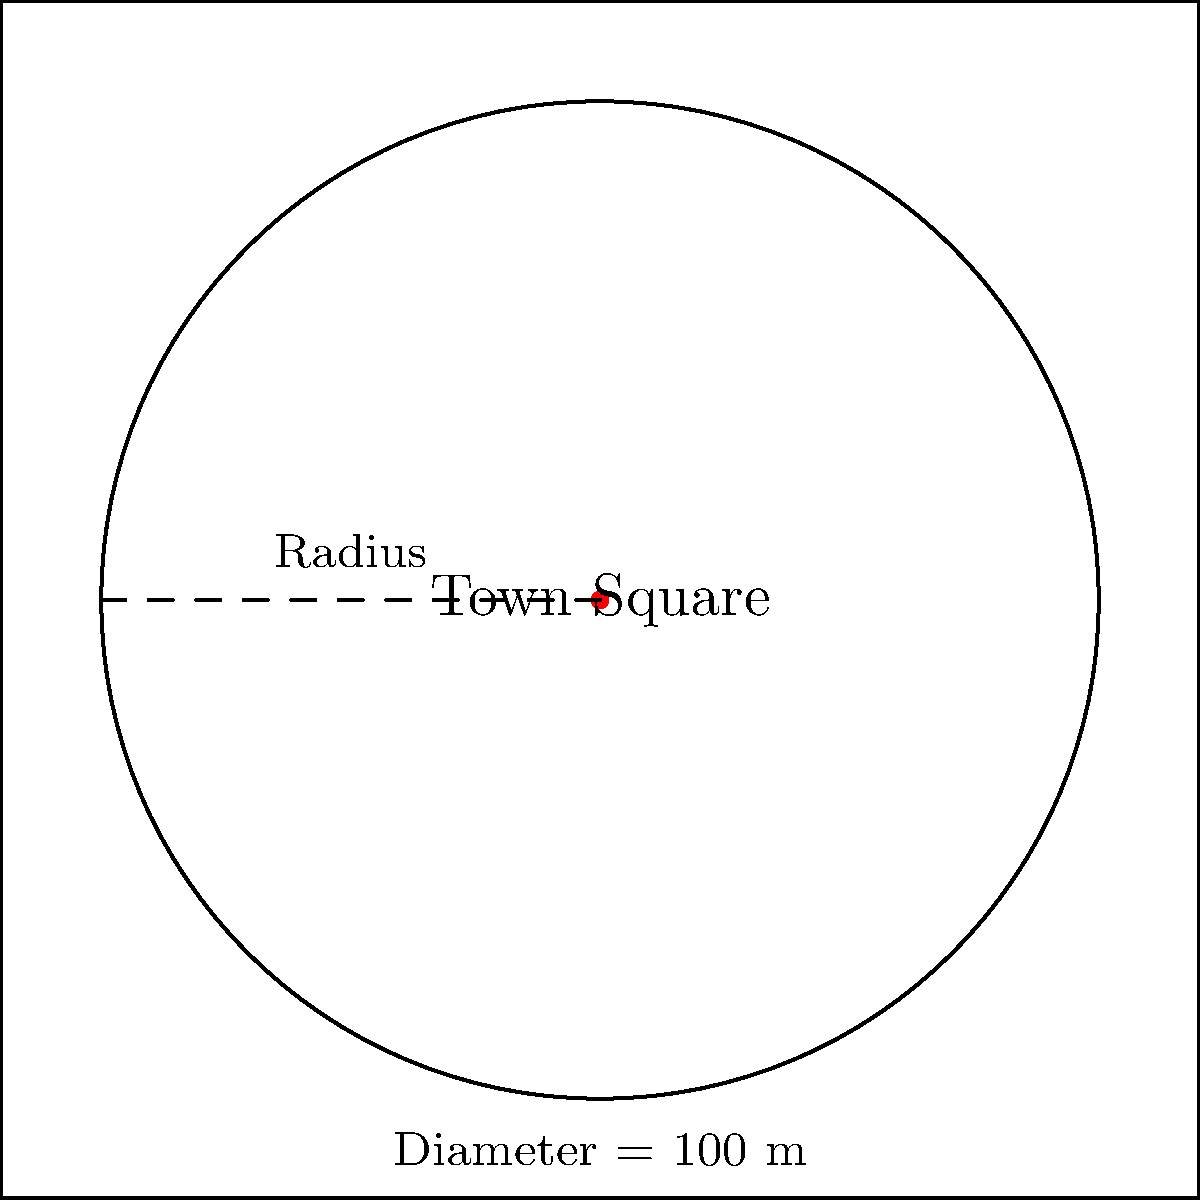In your town's historic photographs, you've noticed a circular town square that was a popular gathering place. If the diameter of this circular square is 100 meters, what is its perimeter? Round your answer to the nearest meter. To find the perimeter of the circular town square, we need to calculate its circumference. Let's break it down step-by-step:

1) The formula for the circumference of a circle is:
   $C = \pi d$, where $C$ is the circumference, $\pi$ is pi, and $d$ is the diameter.

2) We're given that the diameter is 100 meters.

3) Let's substitute these values into the formula:
   $C = \pi \times 100$

4) $\pi$ is approximately 3.14159. So:
   $C \approx 3.14159 \times 100$

5) Calculating this:
   $C \approx 314.159$ meters

6) Rounding to the nearest meter:
   $C \approx 314$ meters

Therefore, the perimeter of the circular town square is approximately 314 meters.
Answer: 314 meters 